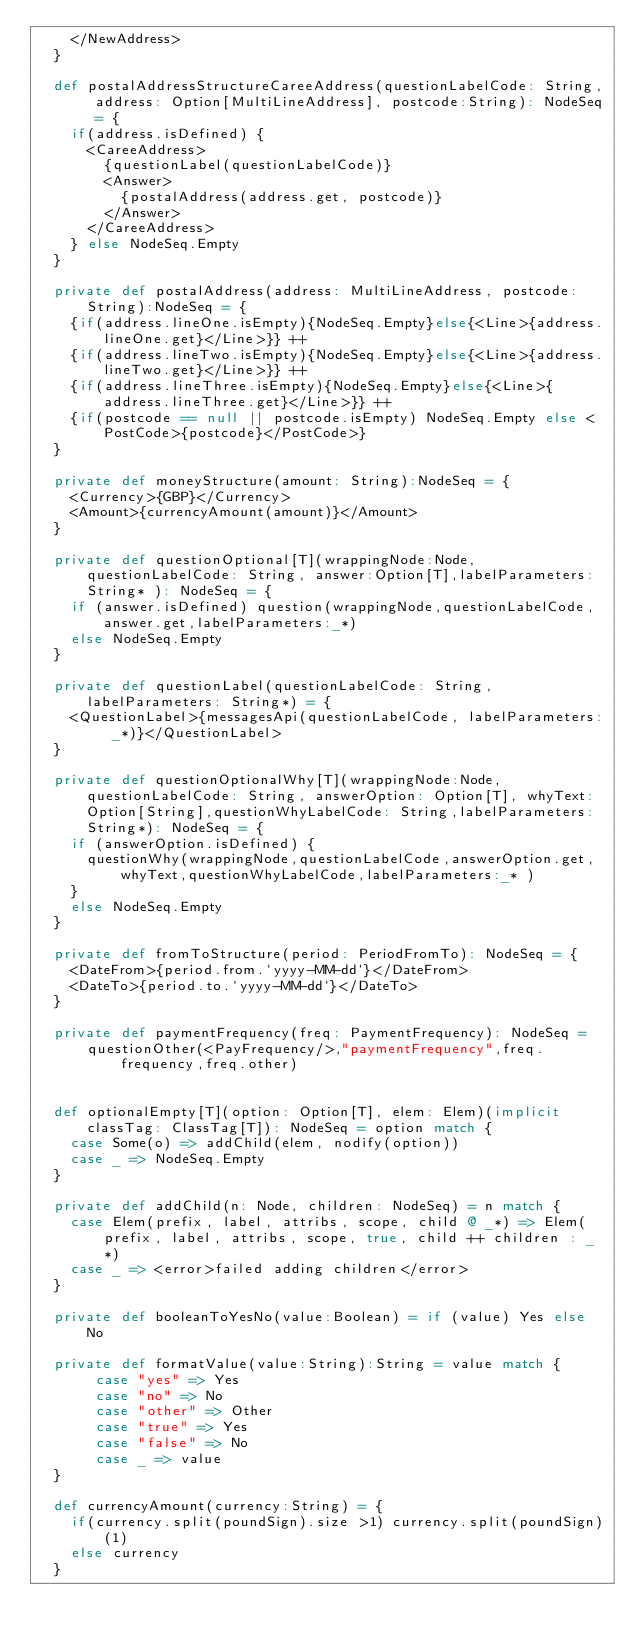<code> <loc_0><loc_0><loc_500><loc_500><_Scala_>    </NewAddress>
  }

  def postalAddressStructureCareeAddress(questionLabelCode: String, address: Option[MultiLineAddress], postcode:String): NodeSeq = {
    if(address.isDefined) {
      <CareeAddress>
        {questionLabel(questionLabelCode)}
        <Answer>
          {postalAddress(address.get, postcode)}
        </Answer>
      </CareeAddress>
    } else NodeSeq.Empty
  }

  private def postalAddress(address: MultiLineAddress, postcode: String):NodeSeq = {
    {if(address.lineOne.isEmpty){NodeSeq.Empty}else{<Line>{address.lineOne.get}</Line>}} ++
    {if(address.lineTwo.isEmpty){NodeSeq.Empty}else{<Line>{address.lineTwo.get}</Line>}} ++
    {if(address.lineThree.isEmpty){NodeSeq.Empty}else{<Line>{address.lineThree.get}</Line>}} ++
    {if(postcode == null || postcode.isEmpty) NodeSeq.Empty else <PostCode>{postcode}</PostCode>}
  }

  private def moneyStructure(amount: String):NodeSeq = {
    <Currency>{GBP}</Currency>
    <Amount>{currencyAmount(amount)}</Amount>
  }

  private def questionOptional[T](wrappingNode:Node,questionLabelCode: String, answer:Option[T],labelParameters: String* ): NodeSeq = {
    if (answer.isDefined) question(wrappingNode,questionLabelCode,answer.get,labelParameters:_*)
    else NodeSeq.Empty
  }

  private def questionLabel(questionLabelCode: String,labelParameters: String*) = {
    <QuestionLabel>{messagesApi(questionLabelCode, labelParameters: _*)}</QuestionLabel>
  }

  private def questionOptionalWhy[T](wrappingNode:Node,questionLabelCode: String, answerOption: Option[T], whyText: Option[String],questionWhyLabelCode: String,labelParameters: String*): NodeSeq = {
    if (answerOption.isDefined) {
      questionWhy(wrappingNode,questionLabelCode,answerOption.get,whyText,questionWhyLabelCode,labelParameters:_* )
    }
    else NodeSeq.Empty
  }

  private def fromToStructure(period: PeriodFromTo): NodeSeq = {
    <DateFrom>{period.from.`yyyy-MM-dd`}</DateFrom>
    <DateTo>{period.to.`yyyy-MM-dd`}</DateTo>
  }

  private def paymentFrequency(freq: PaymentFrequency): NodeSeq =
      questionOther(<PayFrequency/>,"paymentFrequency",freq.frequency,freq.other)


  def optionalEmpty[T](option: Option[T], elem: Elem)(implicit classTag: ClassTag[T]): NodeSeq = option match {
    case Some(o) => addChild(elem, nodify(option))
    case _ => NodeSeq.Empty
  }

  private def addChild(n: Node, children: NodeSeq) = n match {
    case Elem(prefix, label, attribs, scope, child @ _*) => Elem(prefix, label, attribs, scope, true, child ++ children : _*)
    case _ => <error>failed adding children</error>
  }

  private def booleanToYesNo(value:Boolean) = if (value) Yes else No

  private def formatValue(value:String):String = value match {
       case "yes" => Yes
       case "no" => No
       case "other" => Other
       case "true" => Yes
       case "false" => No
       case _ => value
  }

  def currencyAmount(currency:String) = {
    if(currency.split(poundSign).size >1) currency.split(poundSign)(1)
    else currency
  }
</code> 